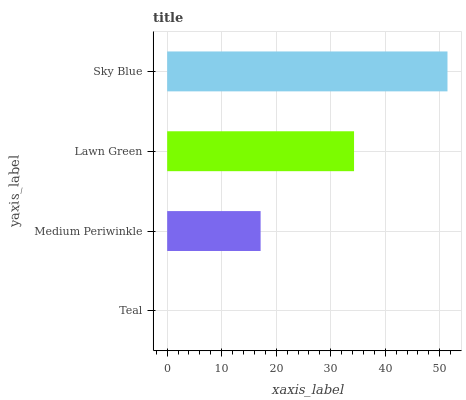Is Teal the minimum?
Answer yes or no. Yes. Is Sky Blue the maximum?
Answer yes or no. Yes. Is Medium Periwinkle the minimum?
Answer yes or no. No. Is Medium Periwinkle the maximum?
Answer yes or no. No. Is Medium Periwinkle greater than Teal?
Answer yes or no. Yes. Is Teal less than Medium Periwinkle?
Answer yes or no. Yes. Is Teal greater than Medium Periwinkle?
Answer yes or no. No. Is Medium Periwinkle less than Teal?
Answer yes or no. No. Is Lawn Green the high median?
Answer yes or no. Yes. Is Medium Periwinkle the low median?
Answer yes or no. Yes. Is Medium Periwinkle the high median?
Answer yes or no. No. Is Sky Blue the low median?
Answer yes or no. No. 